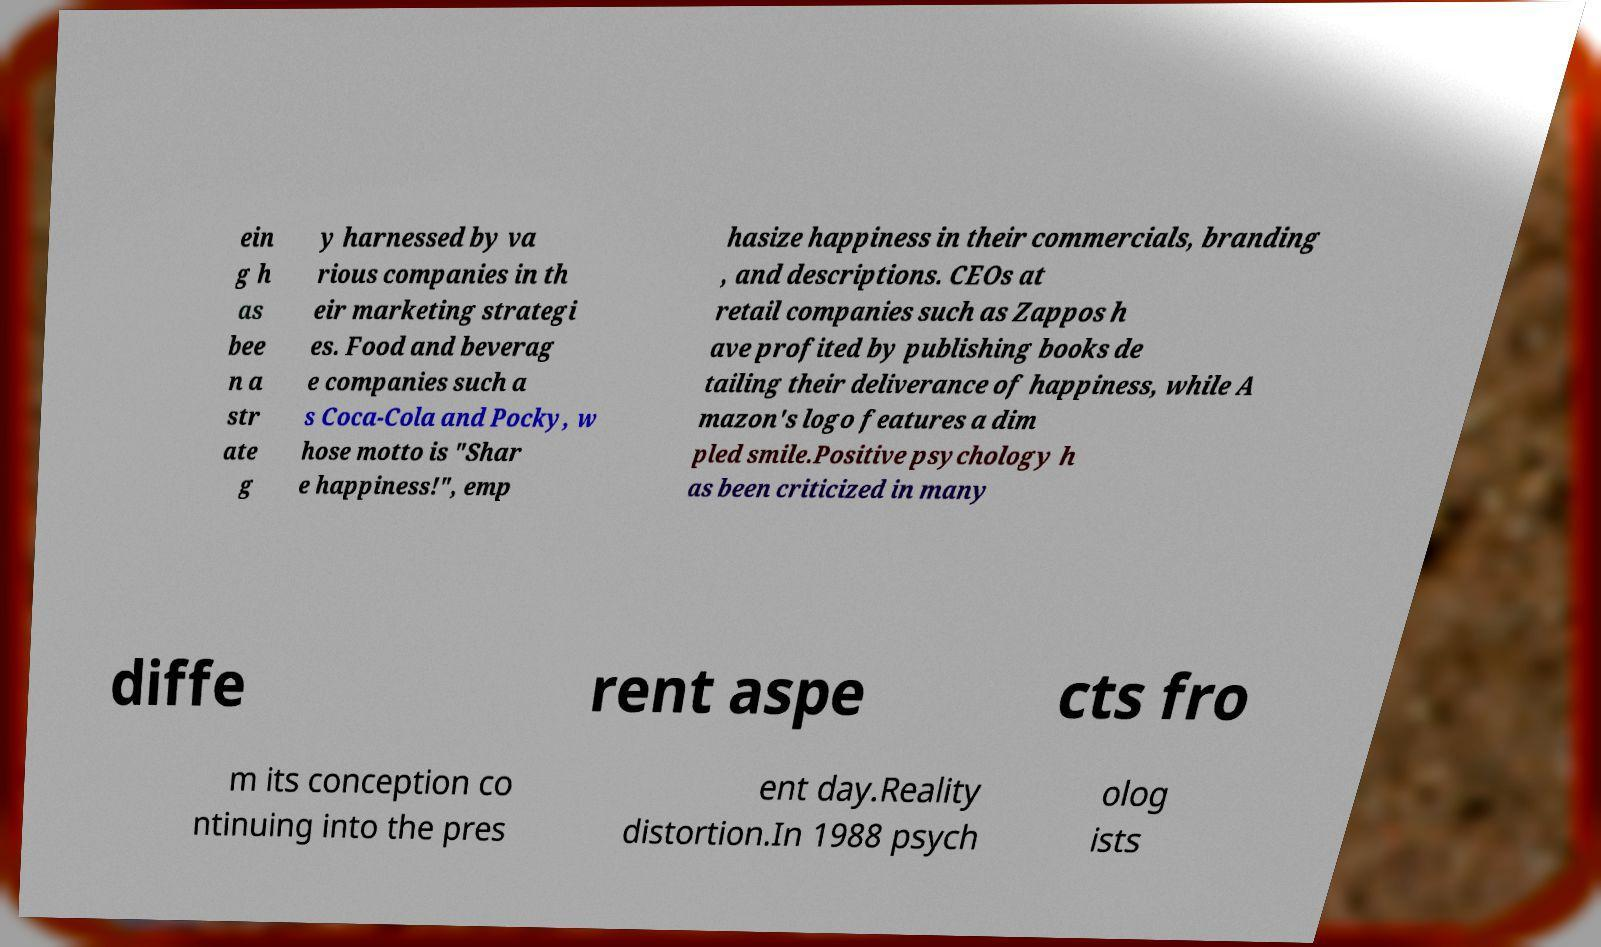For documentation purposes, I need the text within this image transcribed. Could you provide that? ein g h as bee n a str ate g y harnessed by va rious companies in th eir marketing strategi es. Food and beverag e companies such a s Coca-Cola and Pocky, w hose motto is "Shar e happiness!", emp hasize happiness in their commercials, branding , and descriptions. CEOs at retail companies such as Zappos h ave profited by publishing books de tailing their deliverance of happiness, while A mazon's logo features a dim pled smile.Positive psychology h as been criticized in many diffe rent aspe cts fro m its conception co ntinuing into the pres ent day.Reality distortion.In 1988 psych olog ists 